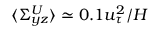<formula> <loc_0><loc_0><loc_500><loc_500>\langle \Sigma _ { y z } ^ { U } \rangle \simeq 0 . 1 u _ { \tau } ^ { 2 } / H</formula> 